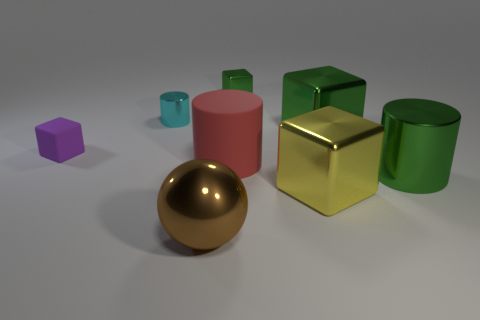What can you infer about the sizes of the objects relative to each other? The sizes of the objects range from small to large, with the sphere and tiny cube being on the smaller end of the spectrum, and the two cylinders and two cubes appear larger, providing a scale of size that adds depth and perspective to the scene. 